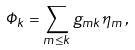<formula> <loc_0><loc_0><loc_500><loc_500>\Phi _ { k } = \sum _ { m \leq k } g _ { m k } \eta _ { m } \, ,</formula> 